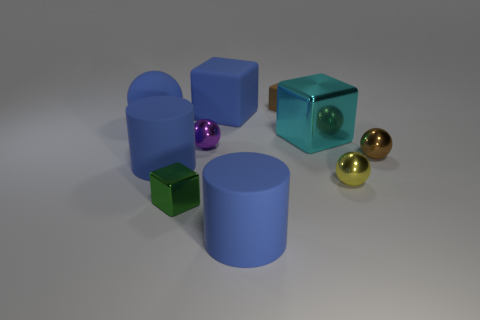Do the large rubber sphere and the big rubber cube have the same color?
Your response must be concise. Yes. There is a metallic thing that is the same color as the tiny matte object; what is its shape?
Your response must be concise. Sphere. There is a matte object that is in front of the green metal cube; does it have the same size as the purple object?
Ensure brevity in your answer.  No. Is there a large object that has the same color as the big rubber cube?
Keep it short and to the point. Yes. What is the size of the cyan cube that is the same material as the tiny yellow sphere?
Ensure brevity in your answer.  Large. Is the number of shiny balls that are on the right side of the small purple thing greater than the number of green blocks that are to the right of the yellow ball?
Provide a succinct answer. Yes. What number of other objects are the same material as the tiny brown sphere?
Offer a terse response. 4. Does the cyan object behind the tiny yellow thing have the same material as the purple thing?
Your answer should be very brief. Yes. The large cyan metallic thing is what shape?
Ensure brevity in your answer.  Cube. Are there more metal cubes behind the brown sphere than tiny cyan shiny balls?
Keep it short and to the point. Yes. 